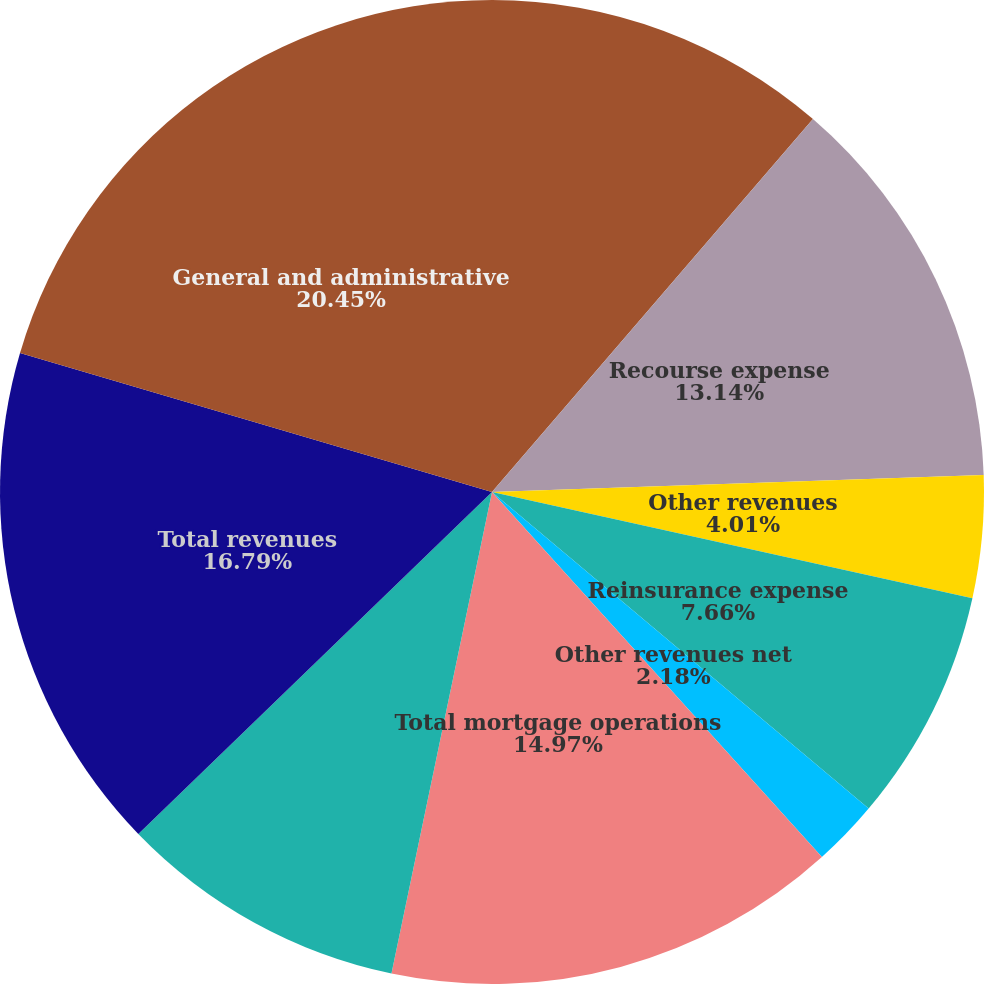Convert chart. <chart><loc_0><loc_0><loc_500><loc_500><pie_chart><fcel>Sale of servicing rights and<fcel>Recourse expense<fcel>Other revenues<fcel>Reinsurance expense<fcel>Other revenues net<fcel>Total mortgage operations<fcel>Title policy premiums net<fcel>Total revenues<fcel>General and administrative<nl><fcel>11.31%<fcel>13.14%<fcel>4.01%<fcel>7.66%<fcel>2.18%<fcel>14.97%<fcel>9.49%<fcel>16.79%<fcel>20.44%<nl></chart> 